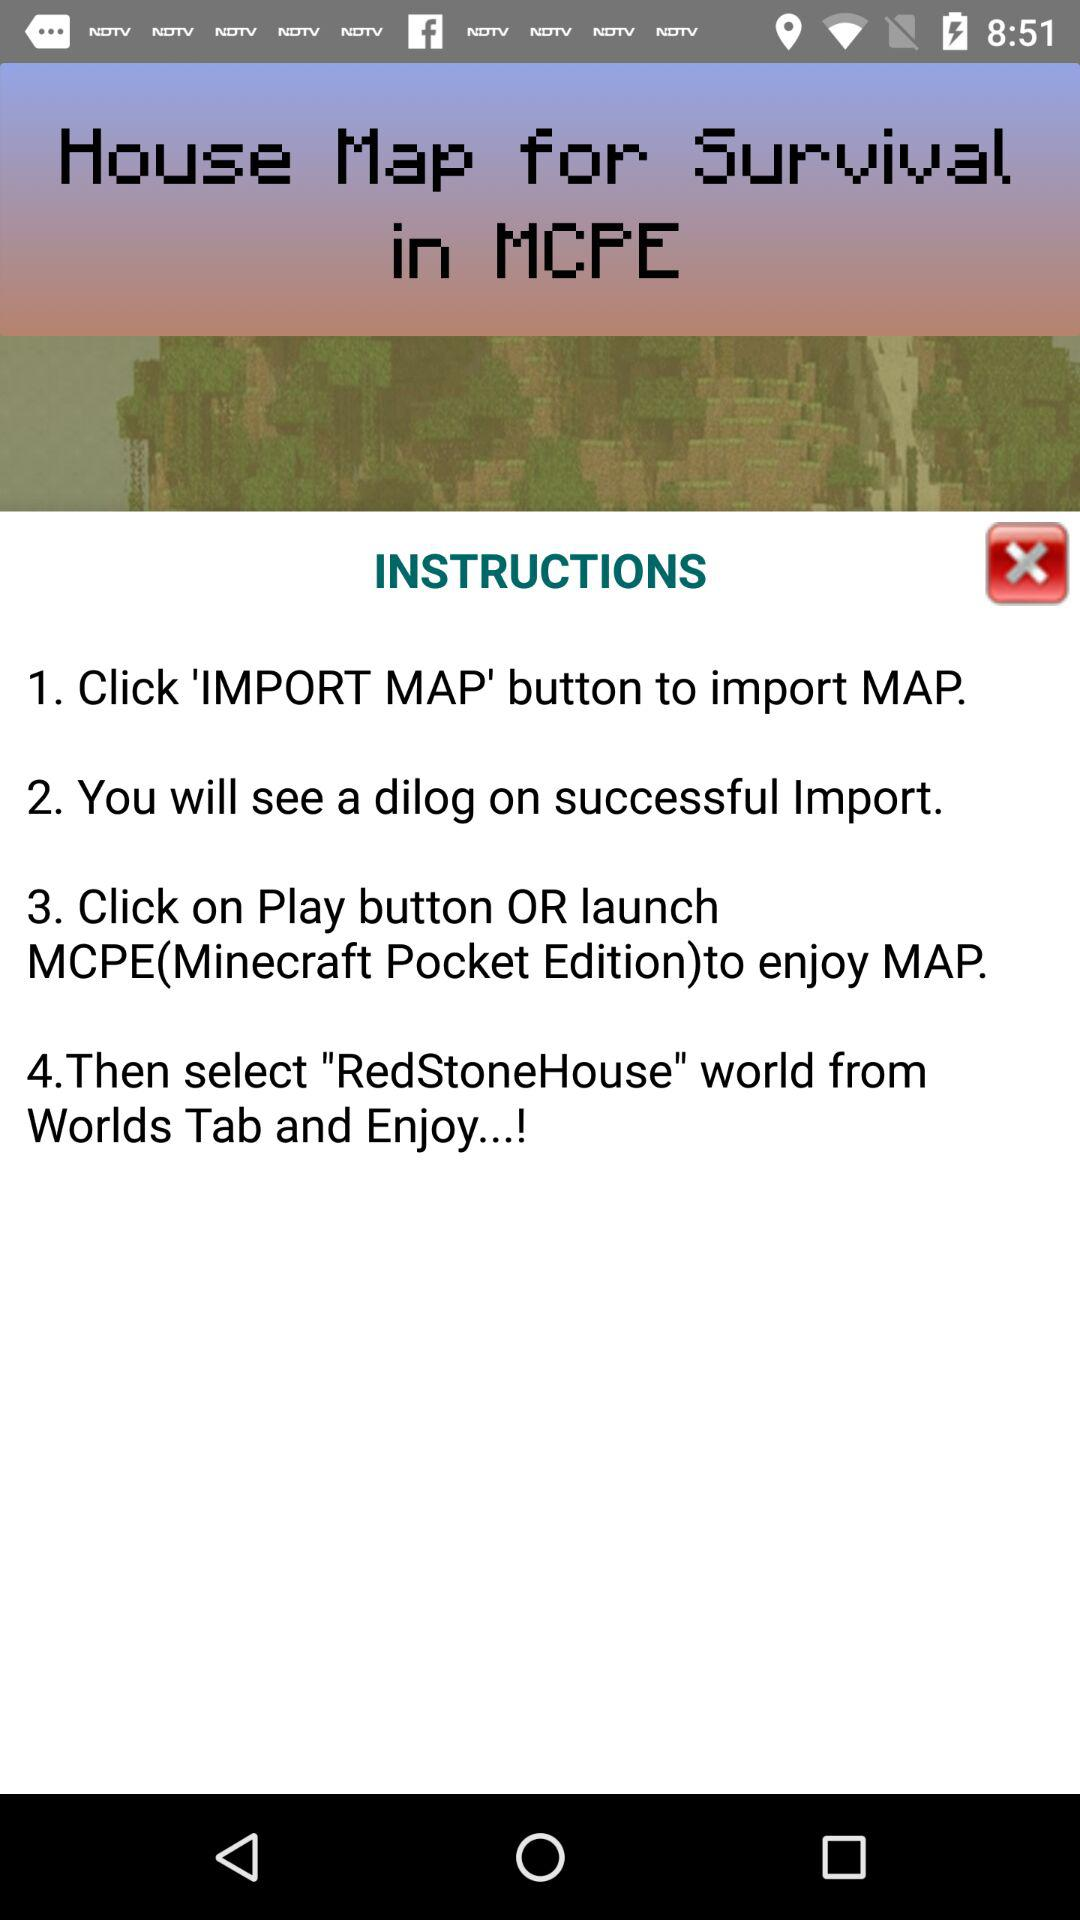What are the instructions to import the map? The instruction to import the map is to click the "IMPORT MAP" button. 